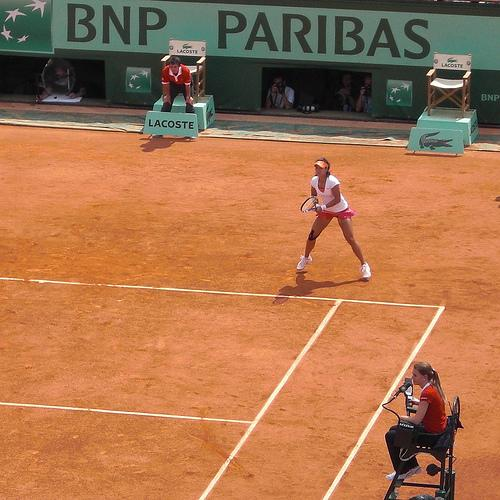Please provide details about the woman's outfit in this image. The woman is wearing a white shirt, red skirt, white shoes, and a visor. In the image, can you spot any unique features on a blue chair? There is an image of an alligator on the blue chair. Are there any objects or characters in the image that require complex reasoning to understand their interactions? Understanding the roles of the tennis player, referee, and media personnel in the context of a tennis match requires some complex reasoning. What kind of seating arrangement is provided for the referee in this scene? The referee sits in a tall chair, watching over the game. Consider the feelings or emotions that the image conveys. The image portrays a competitive and energetic atmosphere during a tennis match. Can you mention any prominent logo present in the image? The bnp paribas logo with four stars in a circle is featured prominently in the upper left corner. Identify the primary action of the woman in the image. The woman is playing tennis and holding a tennis racket. How would you rate the quality of this image in terms of clarity and composition? The image has good clarity and a well-structured composition, featuring different elements of the scene. Count the number of media and photographer dugouts in the image. There are two media and photographer dugouts present. What can you tell about the tennis court and its surface? The tennis court has a red dirt surface and white lines on the ground. Is the woman wearing a blue shirt while holding the tennis racket? The woman is actually wearing a white shirt, not a blue one. Do you see a male tennis umpire wearing a blue uniform? The tennis umpire is actually a female and is wearing red, not blue. Is the tennis court covered in green grass instead of red dirt? The tennis court is actually made of red dirt, not green grass. Are there any animals on the tennis court, like a dog or cat? There is an image of an alligator on a blue chair, but no real animals like dogs or cats are present. Can you find the smallest BNP Paribas logo with only two stars in the bottom right corner? The largest BNP Paribas logo consists of four stars in a circle, and it is positioned in the upper left corner, not the smallest logo with two stars in the bottom right corner. Can you find the man standing on a green chair next to the tennis court? There is a man standing above a blue chair, not a green one. 